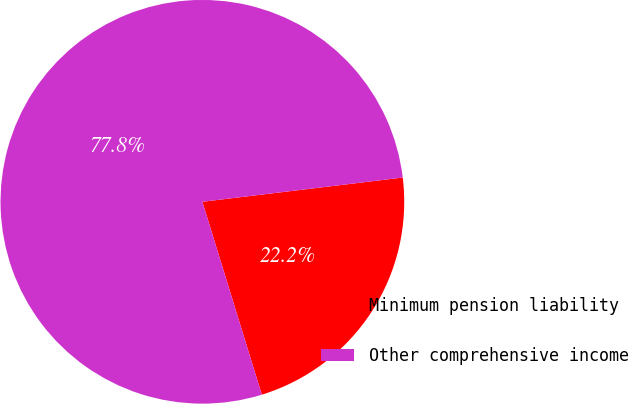<chart> <loc_0><loc_0><loc_500><loc_500><pie_chart><fcel>Minimum pension liability<fcel>Other comprehensive income<nl><fcel>22.16%<fcel>77.84%<nl></chart> 